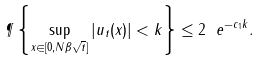<formula> <loc_0><loc_0><loc_500><loc_500>\P \left \{ \sup _ { x \in [ 0 , N \beta \sqrt { t } ] } | u _ { t } ( x ) | < k \right \} \leq 2 \ e ^ { - c _ { 1 } k } .</formula> 